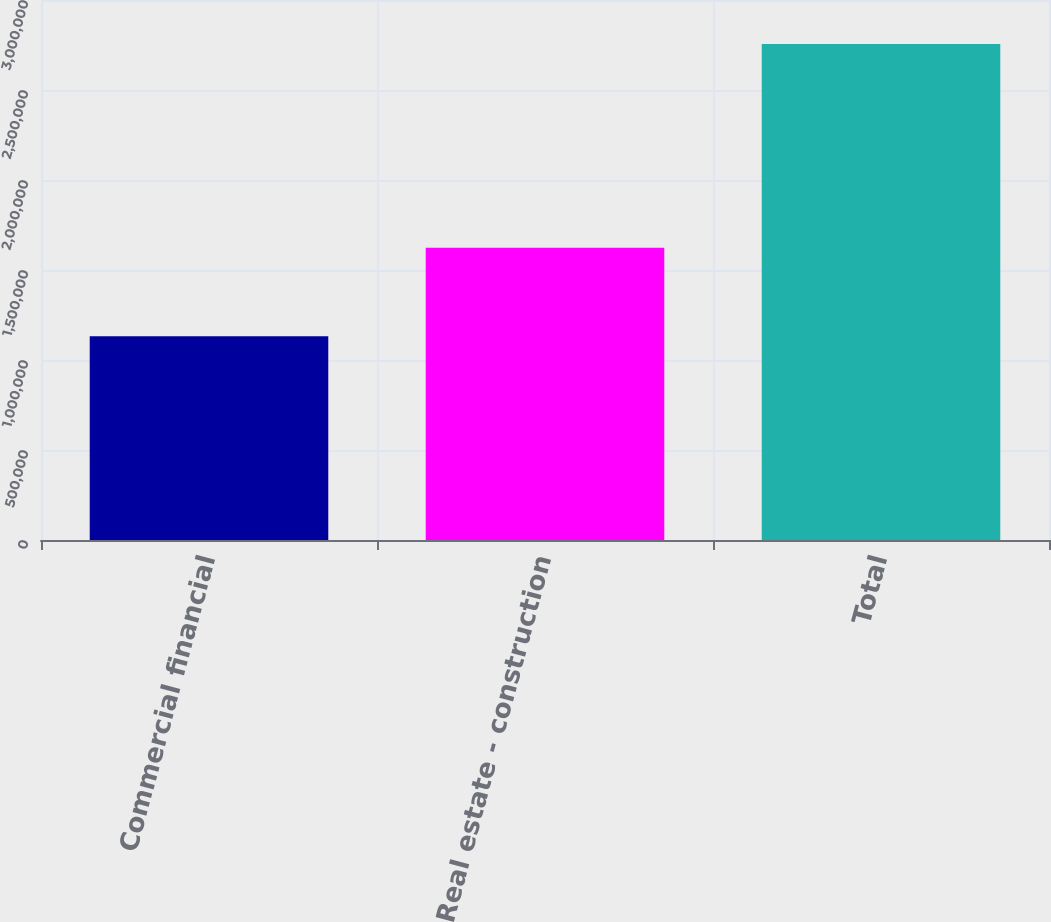<chart> <loc_0><loc_0><loc_500><loc_500><bar_chart><fcel>Commercial financial<fcel>Real estate - construction<fcel>Total<nl><fcel>1.13236e+06<fcel>1.62307e+06<fcel>2.75543e+06<nl></chart> 